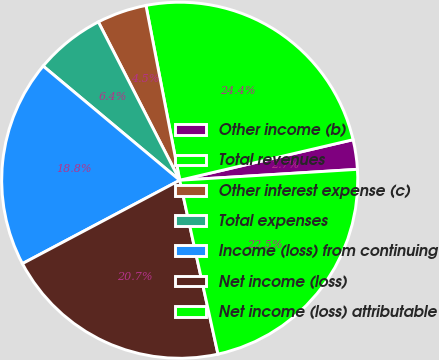Convert chart. <chart><loc_0><loc_0><loc_500><loc_500><pie_chart><fcel>Other income (b)<fcel>Total revenues<fcel>Other interest expense (c)<fcel>Total expenses<fcel>Income (loss) from continuing<fcel>Net income (loss)<fcel>Net income (loss) attributable<nl><fcel>2.68%<fcel>24.38%<fcel>4.52%<fcel>6.36%<fcel>18.84%<fcel>20.69%<fcel>22.53%<nl></chart> 